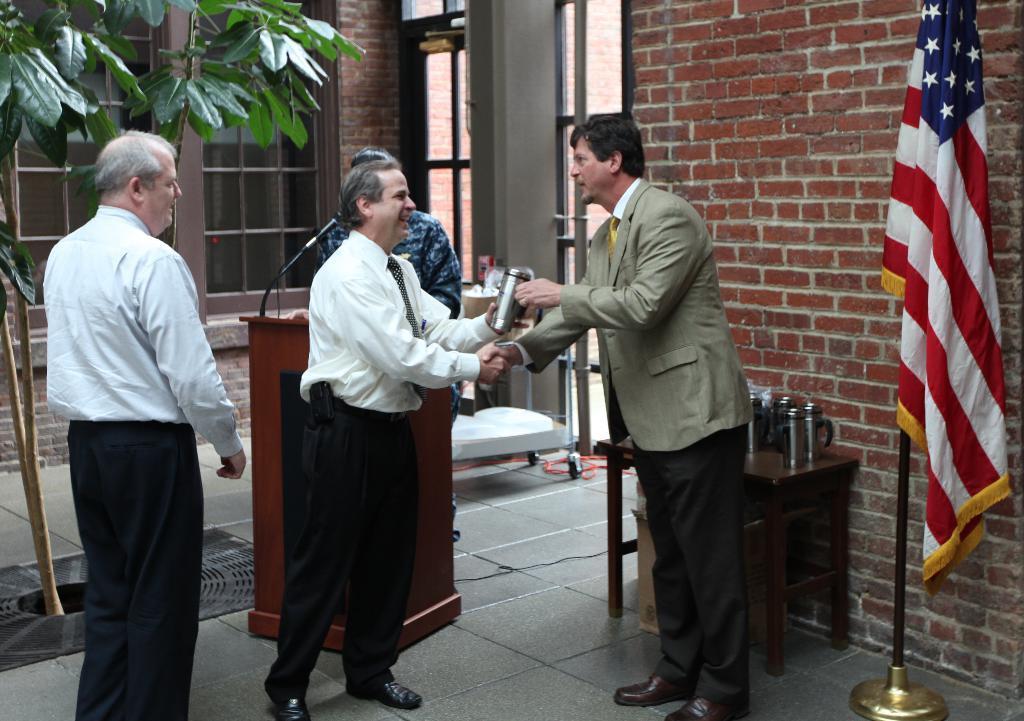Describe this image in one or two sentences. In the picture we can see four people are standing and two persons are shaking hands and holding a bottle and in the background, we can see some person standing near the desk with a microphone and behind him we can see a wall with some windows with glasses and a flag to the pole on the floor. 